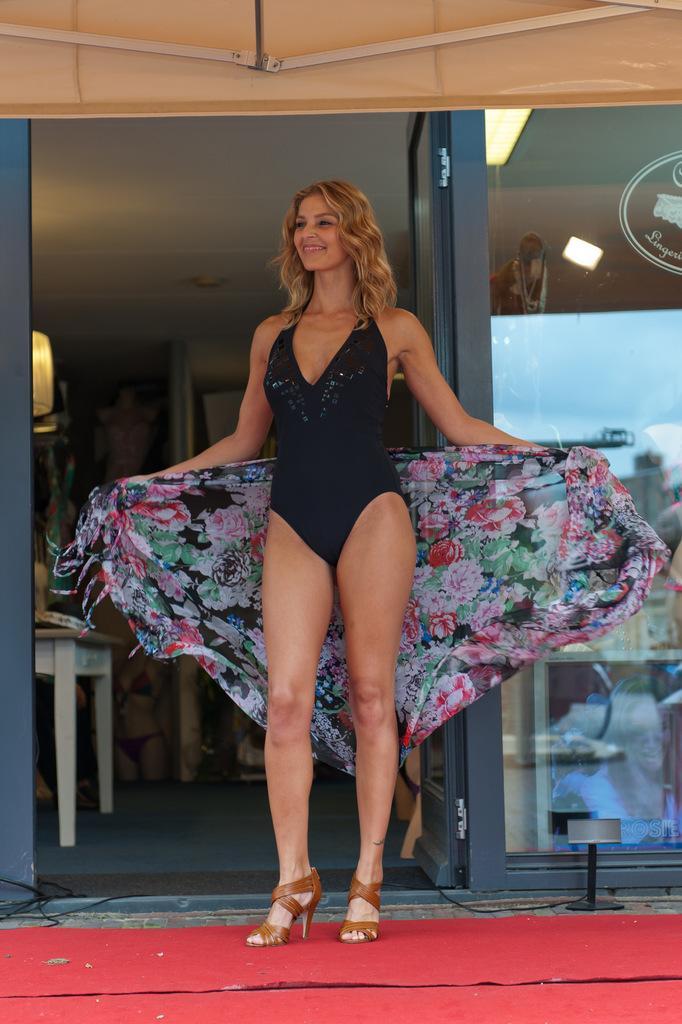Please provide a concise description of this image. There is a lady holding a cloth is smiling and standing on a red carpet. In the back there is a table, door and a glass wall. 